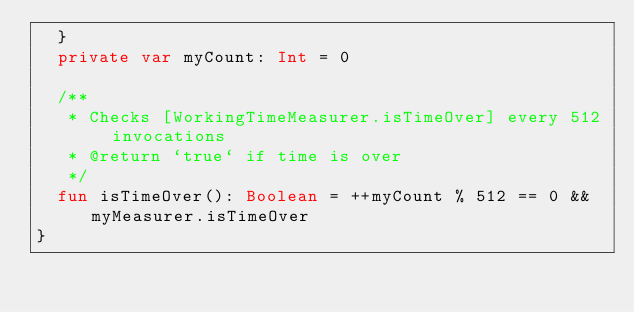Convert code to text. <code><loc_0><loc_0><loc_500><loc_500><_Kotlin_>  }
  private var myCount: Int = 0

  /**
   * Checks [WorkingTimeMeasurer.isTimeOver] every 512 invocations
   * @return `true` if time is over
   */
  fun isTimeOver(): Boolean = ++myCount % 512 == 0 && myMeasurer.isTimeOver
}</code> 